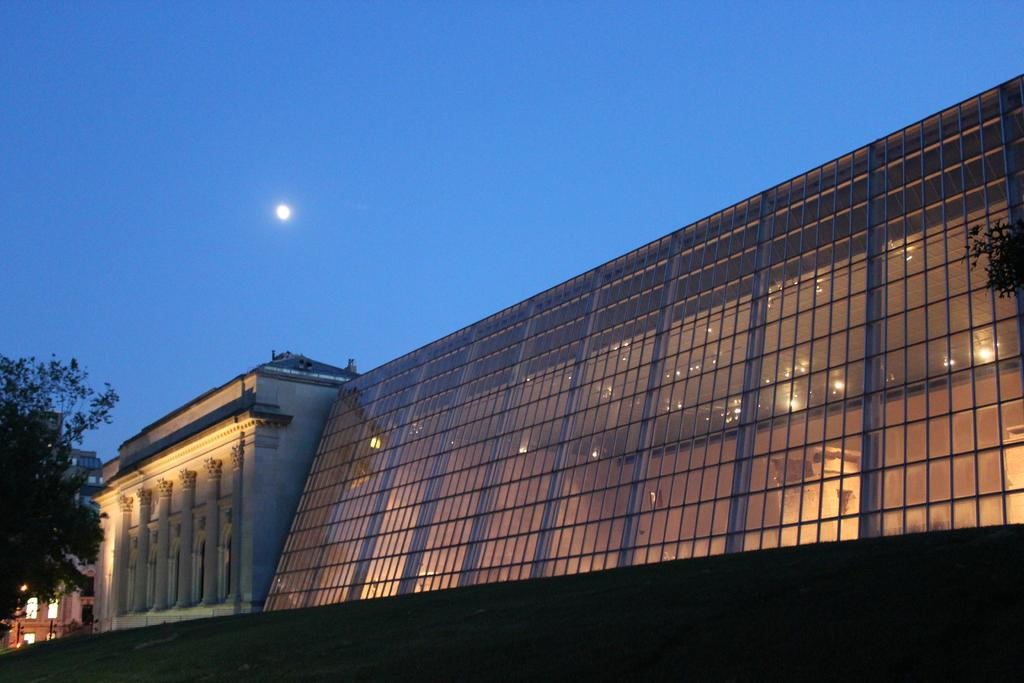What type of structures are present in the image? There is a group of buildings in the image. What other natural elements can be seen in the image? There are trees in the image. What are the vertical structures in the image used for? The poles in the image are likely used for support or signage. What can be seen in the background of the image? The sky is visible in the background of the image. What route does the division take through the buildings in the image? There is no division or route present in the image; it features a group of buildings, trees, poles, and the sky. 